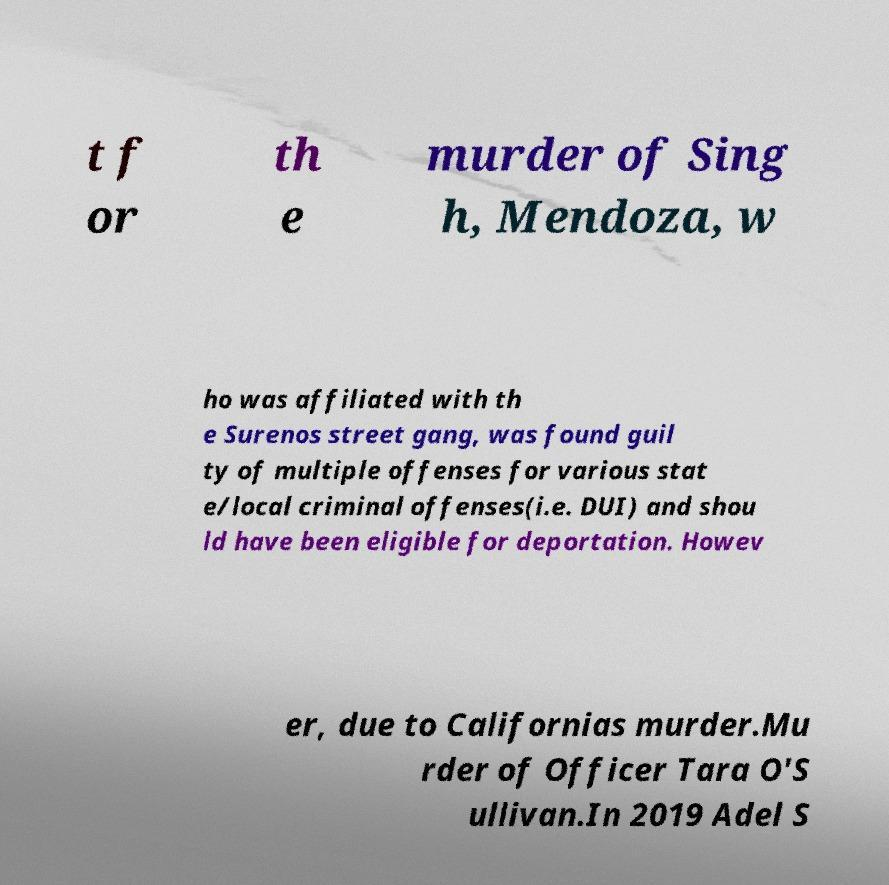There's text embedded in this image that I need extracted. Can you transcribe it verbatim? t f or th e murder of Sing h, Mendoza, w ho was affiliated with th e Surenos street gang, was found guil ty of multiple offenses for various stat e/local criminal offenses(i.e. DUI) and shou ld have been eligible for deportation. Howev er, due to Californias murder.Mu rder of Officer Tara O'S ullivan.In 2019 Adel S 